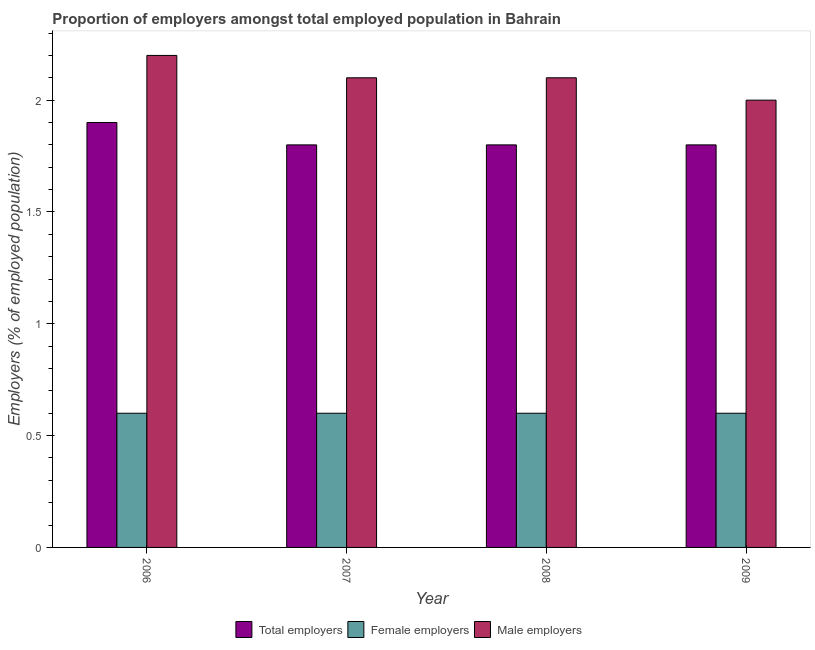Are the number of bars per tick equal to the number of legend labels?
Provide a short and direct response. Yes. Are the number of bars on each tick of the X-axis equal?
Keep it short and to the point. Yes. What is the label of the 2nd group of bars from the left?
Offer a very short reply. 2007. In how many cases, is the number of bars for a given year not equal to the number of legend labels?
Offer a very short reply. 0. What is the percentage of total employers in 2009?
Your answer should be compact. 1.8. Across all years, what is the maximum percentage of total employers?
Your answer should be compact. 1.9. Across all years, what is the minimum percentage of male employers?
Ensure brevity in your answer.  2. What is the total percentage of female employers in the graph?
Offer a very short reply. 2.4. What is the difference between the percentage of total employers in 2006 and that in 2008?
Offer a terse response. 0.1. What is the difference between the percentage of male employers in 2006 and the percentage of female employers in 2008?
Your answer should be compact. 0.1. What is the average percentage of male employers per year?
Provide a succinct answer. 2.1. In the year 2007, what is the difference between the percentage of female employers and percentage of male employers?
Your answer should be very brief. 0. What is the ratio of the percentage of total employers in 2006 to that in 2007?
Your answer should be compact. 1.06. What is the difference between the highest and the second highest percentage of male employers?
Offer a terse response. 0.1. What is the difference between the highest and the lowest percentage of male employers?
Provide a succinct answer. 0.2. What does the 2nd bar from the left in 2007 represents?
Keep it short and to the point. Female employers. What does the 2nd bar from the right in 2007 represents?
Give a very brief answer. Female employers. How many years are there in the graph?
Offer a terse response. 4. What is the difference between two consecutive major ticks on the Y-axis?
Provide a short and direct response. 0.5. How are the legend labels stacked?
Provide a short and direct response. Horizontal. What is the title of the graph?
Your response must be concise. Proportion of employers amongst total employed population in Bahrain. Does "Male employers" appear as one of the legend labels in the graph?
Provide a short and direct response. Yes. What is the label or title of the X-axis?
Your answer should be very brief. Year. What is the label or title of the Y-axis?
Your response must be concise. Employers (% of employed population). What is the Employers (% of employed population) in Total employers in 2006?
Your answer should be compact. 1.9. What is the Employers (% of employed population) in Female employers in 2006?
Keep it short and to the point. 0.6. What is the Employers (% of employed population) of Male employers in 2006?
Give a very brief answer. 2.2. What is the Employers (% of employed population) in Total employers in 2007?
Make the answer very short. 1.8. What is the Employers (% of employed population) of Female employers in 2007?
Provide a short and direct response. 0.6. What is the Employers (% of employed population) of Male employers in 2007?
Provide a short and direct response. 2.1. What is the Employers (% of employed population) in Total employers in 2008?
Offer a very short reply. 1.8. What is the Employers (% of employed population) of Female employers in 2008?
Your answer should be compact. 0.6. What is the Employers (% of employed population) of Male employers in 2008?
Your answer should be compact. 2.1. What is the Employers (% of employed population) in Total employers in 2009?
Offer a terse response. 1.8. What is the Employers (% of employed population) in Female employers in 2009?
Offer a terse response. 0.6. What is the Employers (% of employed population) of Male employers in 2009?
Offer a very short reply. 2. Across all years, what is the maximum Employers (% of employed population) of Total employers?
Your answer should be very brief. 1.9. Across all years, what is the maximum Employers (% of employed population) in Female employers?
Give a very brief answer. 0.6. Across all years, what is the maximum Employers (% of employed population) in Male employers?
Give a very brief answer. 2.2. Across all years, what is the minimum Employers (% of employed population) of Total employers?
Offer a terse response. 1.8. Across all years, what is the minimum Employers (% of employed population) in Female employers?
Your answer should be very brief. 0.6. Across all years, what is the minimum Employers (% of employed population) of Male employers?
Provide a succinct answer. 2. What is the total Employers (% of employed population) in Total employers in the graph?
Provide a short and direct response. 7.3. What is the total Employers (% of employed population) in Male employers in the graph?
Provide a short and direct response. 8.4. What is the difference between the Employers (% of employed population) in Male employers in 2006 and that in 2007?
Provide a succinct answer. 0.1. What is the difference between the Employers (% of employed population) in Male employers in 2006 and that in 2008?
Your answer should be compact. 0.1. What is the difference between the Employers (% of employed population) of Female employers in 2006 and that in 2009?
Make the answer very short. 0. What is the difference between the Employers (% of employed population) of Total employers in 2007 and that in 2008?
Make the answer very short. 0. What is the difference between the Employers (% of employed population) of Female employers in 2007 and that in 2009?
Keep it short and to the point. 0. What is the difference between the Employers (% of employed population) in Male employers in 2007 and that in 2009?
Provide a succinct answer. 0.1. What is the difference between the Employers (% of employed population) of Total employers in 2006 and the Employers (% of employed population) of Female employers in 2007?
Your answer should be compact. 1.3. What is the difference between the Employers (% of employed population) of Female employers in 2006 and the Employers (% of employed population) of Male employers in 2007?
Your response must be concise. -1.5. What is the difference between the Employers (% of employed population) in Total employers in 2006 and the Employers (% of employed population) in Male employers in 2008?
Give a very brief answer. -0.2. What is the difference between the Employers (% of employed population) in Total employers in 2006 and the Employers (% of employed population) in Female employers in 2009?
Give a very brief answer. 1.3. What is the difference between the Employers (% of employed population) in Total employers in 2006 and the Employers (% of employed population) in Male employers in 2009?
Keep it short and to the point. -0.1. What is the difference between the Employers (% of employed population) in Total employers in 2007 and the Employers (% of employed population) in Female employers in 2008?
Your answer should be compact. 1.2. What is the difference between the Employers (% of employed population) of Total employers in 2007 and the Employers (% of employed population) of Male employers in 2008?
Keep it short and to the point. -0.3. What is the difference between the Employers (% of employed population) in Total employers in 2008 and the Employers (% of employed population) in Female employers in 2009?
Your answer should be very brief. 1.2. What is the average Employers (% of employed population) of Total employers per year?
Provide a succinct answer. 1.82. In the year 2006, what is the difference between the Employers (% of employed population) in Total employers and Employers (% of employed population) in Female employers?
Provide a short and direct response. 1.3. In the year 2009, what is the difference between the Employers (% of employed population) in Total employers and Employers (% of employed population) in Male employers?
Make the answer very short. -0.2. What is the ratio of the Employers (% of employed population) of Total employers in 2006 to that in 2007?
Provide a short and direct response. 1.06. What is the ratio of the Employers (% of employed population) of Female employers in 2006 to that in 2007?
Give a very brief answer. 1. What is the ratio of the Employers (% of employed population) in Male employers in 2006 to that in 2007?
Keep it short and to the point. 1.05. What is the ratio of the Employers (% of employed population) in Total employers in 2006 to that in 2008?
Provide a succinct answer. 1.06. What is the ratio of the Employers (% of employed population) in Male employers in 2006 to that in 2008?
Offer a terse response. 1.05. What is the ratio of the Employers (% of employed population) in Total employers in 2006 to that in 2009?
Your answer should be compact. 1.06. What is the ratio of the Employers (% of employed population) of Male employers in 2006 to that in 2009?
Your answer should be compact. 1.1. What is the ratio of the Employers (% of employed population) in Female employers in 2007 to that in 2008?
Provide a succinct answer. 1. What is the ratio of the Employers (% of employed population) in Female employers in 2007 to that in 2009?
Your response must be concise. 1. What is the ratio of the Employers (% of employed population) of Male employers in 2007 to that in 2009?
Keep it short and to the point. 1.05. What is the ratio of the Employers (% of employed population) in Total employers in 2008 to that in 2009?
Ensure brevity in your answer.  1. What is the ratio of the Employers (% of employed population) in Female employers in 2008 to that in 2009?
Provide a succinct answer. 1. What is the difference between the highest and the second highest Employers (% of employed population) in Total employers?
Keep it short and to the point. 0.1. What is the difference between the highest and the second highest Employers (% of employed population) in Male employers?
Provide a short and direct response. 0.1. What is the difference between the highest and the lowest Employers (% of employed population) of Total employers?
Offer a terse response. 0.1. What is the difference between the highest and the lowest Employers (% of employed population) in Female employers?
Give a very brief answer. 0. 